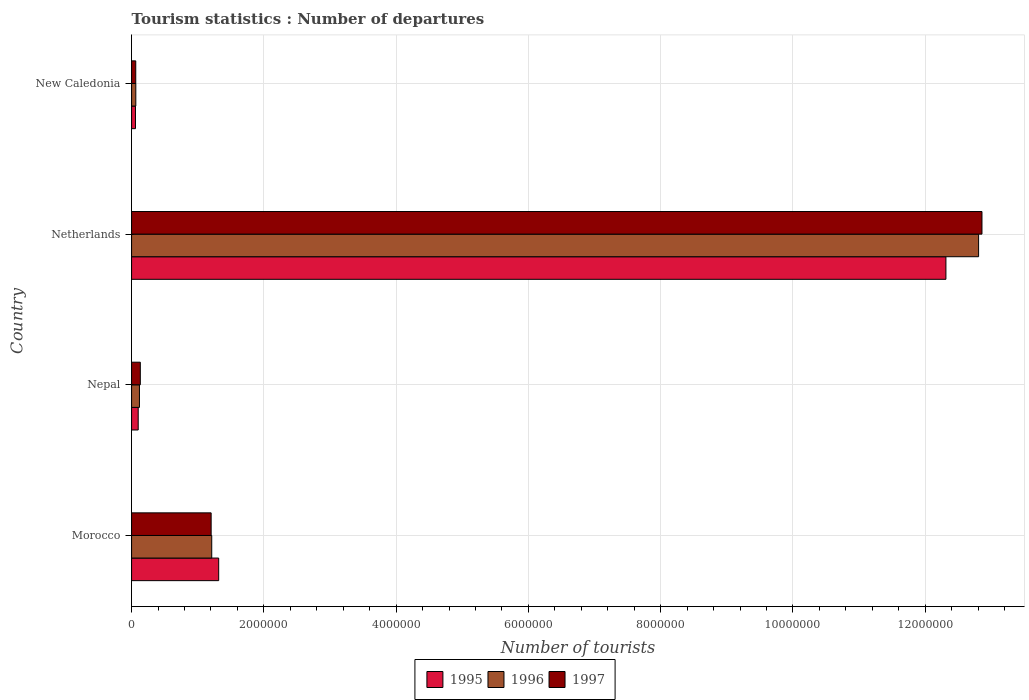How many different coloured bars are there?
Give a very brief answer. 3. Are the number of bars per tick equal to the number of legend labels?
Give a very brief answer. Yes. How many bars are there on the 1st tick from the bottom?
Give a very brief answer. 3. What is the label of the 2nd group of bars from the top?
Keep it short and to the point. Netherlands. In how many cases, is the number of bars for a given country not equal to the number of legend labels?
Keep it short and to the point. 0. What is the number of tourist departures in 1996 in Morocco?
Your answer should be very brief. 1.21e+06. Across all countries, what is the maximum number of tourist departures in 1996?
Give a very brief answer. 1.28e+07. Across all countries, what is the minimum number of tourist departures in 1995?
Ensure brevity in your answer.  5.90e+04. In which country was the number of tourist departures in 1996 maximum?
Your answer should be very brief. Netherlands. In which country was the number of tourist departures in 1997 minimum?
Keep it short and to the point. New Caledonia. What is the total number of tourist departures in 1996 in the graph?
Give a very brief answer. 1.42e+07. What is the difference between the number of tourist departures in 1995 in Nepal and that in Netherlands?
Your answer should be compact. -1.22e+07. What is the difference between the number of tourist departures in 1996 in Nepal and the number of tourist departures in 1997 in New Caledonia?
Make the answer very short. 5.60e+04. What is the average number of tourist departures in 1997 per country?
Your answer should be very brief. 3.56e+06. What is the difference between the number of tourist departures in 1995 and number of tourist departures in 1996 in Nepal?
Offer a very short reply. -1.90e+04. What is the ratio of the number of tourist departures in 1996 in Morocco to that in Nepal?
Your answer should be very brief. 10.18. Is the number of tourist departures in 1995 in Nepal less than that in Netherlands?
Provide a short and direct response. Yes. Is the difference between the number of tourist departures in 1995 in Nepal and Netherlands greater than the difference between the number of tourist departures in 1996 in Nepal and Netherlands?
Your answer should be compact. Yes. What is the difference between the highest and the second highest number of tourist departures in 1997?
Your response must be concise. 1.17e+07. What is the difference between the highest and the lowest number of tourist departures in 1995?
Ensure brevity in your answer.  1.23e+07. Is the sum of the number of tourist departures in 1995 in Morocco and Netherlands greater than the maximum number of tourist departures in 1996 across all countries?
Make the answer very short. Yes. What does the 1st bar from the top in Nepal represents?
Provide a succinct answer. 1997. What does the 1st bar from the bottom in Nepal represents?
Your response must be concise. 1995. Is it the case that in every country, the sum of the number of tourist departures in 1997 and number of tourist departures in 1995 is greater than the number of tourist departures in 1996?
Your answer should be very brief. Yes. How many bars are there?
Give a very brief answer. 12. Are the values on the major ticks of X-axis written in scientific E-notation?
Give a very brief answer. No. Does the graph contain grids?
Ensure brevity in your answer.  Yes. How many legend labels are there?
Your response must be concise. 3. What is the title of the graph?
Offer a terse response. Tourism statistics : Number of departures. Does "1966" appear as one of the legend labels in the graph?
Your response must be concise. No. What is the label or title of the X-axis?
Your answer should be compact. Number of tourists. What is the Number of tourists of 1995 in Morocco?
Your answer should be compact. 1.32e+06. What is the Number of tourists in 1996 in Morocco?
Ensure brevity in your answer.  1.21e+06. What is the Number of tourists in 1997 in Morocco?
Provide a short and direct response. 1.20e+06. What is the Number of tourists in 1995 in Nepal?
Give a very brief answer. 1.00e+05. What is the Number of tourists in 1996 in Nepal?
Your response must be concise. 1.19e+05. What is the Number of tourists in 1997 in Nepal?
Provide a short and direct response. 1.32e+05. What is the Number of tourists of 1995 in Netherlands?
Keep it short and to the point. 1.23e+07. What is the Number of tourists in 1996 in Netherlands?
Offer a terse response. 1.28e+07. What is the Number of tourists in 1997 in Netherlands?
Provide a short and direct response. 1.29e+07. What is the Number of tourists of 1995 in New Caledonia?
Make the answer very short. 5.90e+04. What is the Number of tourists in 1996 in New Caledonia?
Your answer should be very brief. 6.40e+04. What is the Number of tourists in 1997 in New Caledonia?
Offer a terse response. 6.30e+04. Across all countries, what is the maximum Number of tourists in 1995?
Give a very brief answer. 1.23e+07. Across all countries, what is the maximum Number of tourists of 1996?
Provide a succinct answer. 1.28e+07. Across all countries, what is the maximum Number of tourists in 1997?
Keep it short and to the point. 1.29e+07. Across all countries, what is the minimum Number of tourists in 1995?
Offer a very short reply. 5.90e+04. Across all countries, what is the minimum Number of tourists of 1996?
Provide a succinct answer. 6.40e+04. Across all countries, what is the minimum Number of tourists of 1997?
Your answer should be very brief. 6.30e+04. What is the total Number of tourists of 1995 in the graph?
Make the answer very short. 1.38e+07. What is the total Number of tourists of 1996 in the graph?
Make the answer very short. 1.42e+07. What is the total Number of tourists of 1997 in the graph?
Your answer should be very brief. 1.43e+07. What is the difference between the Number of tourists in 1995 in Morocco and that in Nepal?
Your response must be concise. 1.22e+06. What is the difference between the Number of tourists in 1996 in Morocco and that in Nepal?
Keep it short and to the point. 1.09e+06. What is the difference between the Number of tourists of 1997 in Morocco and that in Nepal?
Offer a terse response. 1.07e+06. What is the difference between the Number of tourists in 1995 in Morocco and that in Netherlands?
Offer a very short reply. -1.10e+07. What is the difference between the Number of tourists in 1996 in Morocco and that in Netherlands?
Make the answer very short. -1.16e+07. What is the difference between the Number of tourists in 1997 in Morocco and that in Netherlands?
Give a very brief answer. -1.17e+07. What is the difference between the Number of tourists in 1995 in Morocco and that in New Caledonia?
Offer a very short reply. 1.26e+06. What is the difference between the Number of tourists of 1996 in Morocco and that in New Caledonia?
Provide a succinct answer. 1.15e+06. What is the difference between the Number of tourists of 1997 in Morocco and that in New Caledonia?
Offer a very short reply. 1.14e+06. What is the difference between the Number of tourists of 1995 in Nepal and that in Netherlands?
Provide a succinct answer. -1.22e+07. What is the difference between the Number of tourists in 1996 in Nepal and that in Netherlands?
Make the answer very short. -1.27e+07. What is the difference between the Number of tourists in 1997 in Nepal and that in Netherlands?
Make the answer very short. -1.27e+07. What is the difference between the Number of tourists of 1995 in Nepal and that in New Caledonia?
Your response must be concise. 4.10e+04. What is the difference between the Number of tourists of 1996 in Nepal and that in New Caledonia?
Keep it short and to the point. 5.50e+04. What is the difference between the Number of tourists of 1997 in Nepal and that in New Caledonia?
Provide a succinct answer. 6.90e+04. What is the difference between the Number of tourists of 1995 in Netherlands and that in New Caledonia?
Your response must be concise. 1.23e+07. What is the difference between the Number of tourists in 1996 in Netherlands and that in New Caledonia?
Your answer should be very brief. 1.27e+07. What is the difference between the Number of tourists in 1997 in Netherlands and that in New Caledonia?
Keep it short and to the point. 1.28e+07. What is the difference between the Number of tourists in 1995 in Morocco and the Number of tourists in 1996 in Nepal?
Make the answer very short. 1.20e+06. What is the difference between the Number of tourists of 1995 in Morocco and the Number of tourists of 1997 in Nepal?
Your answer should be very brief. 1.18e+06. What is the difference between the Number of tourists in 1996 in Morocco and the Number of tourists in 1997 in Nepal?
Provide a succinct answer. 1.08e+06. What is the difference between the Number of tourists of 1995 in Morocco and the Number of tourists of 1996 in Netherlands?
Offer a terse response. -1.15e+07. What is the difference between the Number of tourists in 1995 in Morocco and the Number of tourists in 1997 in Netherlands?
Give a very brief answer. -1.15e+07. What is the difference between the Number of tourists of 1996 in Morocco and the Number of tourists of 1997 in Netherlands?
Give a very brief answer. -1.16e+07. What is the difference between the Number of tourists of 1995 in Morocco and the Number of tourists of 1996 in New Caledonia?
Offer a terse response. 1.25e+06. What is the difference between the Number of tourists of 1995 in Morocco and the Number of tourists of 1997 in New Caledonia?
Make the answer very short. 1.25e+06. What is the difference between the Number of tourists in 1996 in Morocco and the Number of tourists in 1997 in New Caledonia?
Keep it short and to the point. 1.15e+06. What is the difference between the Number of tourists of 1995 in Nepal and the Number of tourists of 1996 in Netherlands?
Keep it short and to the point. -1.27e+07. What is the difference between the Number of tourists in 1995 in Nepal and the Number of tourists in 1997 in Netherlands?
Your answer should be compact. -1.28e+07. What is the difference between the Number of tourists of 1996 in Nepal and the Number of tourists of 1997 in Netherlands?
Ensure brevity in your answer.  -1.27e+07. What is the difference between the Number of tourists of 1995 in Nepal and the Number of tourists of 1996 in New Caledonia?
Give a very brief answer. 3.60e+04. What is the difference between the Number of tourists in 1995 in Nepal and the Number of tourists in 1997 in New Caledonia?
Give a very brief answer. 3.70e+04. What is the difference between the Number of tourists in 1996 in Nepal and the Number of tourists in 1997 in New Caledonia?
Offer a very short reply. 5.60e+04. What is the difference between the Number of tourists in 1995 in Netherlands and the Number of tourists in 1996 in New Caledonia?
Give a very brief answer. 1.22e+07. What is the difference between the Number of tourists in 1995 in Netherlands and the Number of tourists in 1997 in New Caledonia?
Your answer should be very brief. 1.22e+07. What is the difference between the Number of tourists of 1996 in Netherlands and the Number of tourists of 1997 in New Caledonia?
Provide a succinct answer. 1.27e+07. What is the average Number of tourists of 1995 per country?
Give a very brief answer. 3.45e+06. What is the average Number of tourists in 1996 per country?
Provide a short and direct response. 3.55e+06. What is the average Number of tourists of 1997 per country?
Your answer should be compact. 3.56e+06. What is the difference between the Number of tourists of 1995 and Number of tourists of 1996 in Morocco?
Provide a short and direct response. 1.05e+05. What is the difference between the Number of tourists in 1995 and Number of tourists in 1997 in Morocco?
Make the answer very short. 1.14e+05. What is the difference between the Number of tourists in 1996 and Number of tourists in 1997 in Morocco?
Your response must be concise. 9000. What is the difference between the Number of tourists of 1995 and Number of tourists of 1996 in Nepal?
Keep it short and to the point. -1.90e+04. What is the difference between the Number of tourists in 1995 and Number of tourists in 1997 in Nepal?
Your answer should be compact. -3.20e+04. What is the difference between the Number of tourists of 1996 and Number of tourists of 1997 in Nepal?
Your answer should be compact. -1.30e+04. What is the difference between the Number of tourists of 1995 and Number of tourists of 1996 in Netherlands?
Offer a very short reply. -4.94e+05. What is the difference between the Number of tourists of 1995 and Number of tourists of 1997 in Netherlands?
Make the answer very short. -5.45e+05. What is the difference between the Number of tourists of 1996 and Number of tourists of 1997 in Netherlands?
Your response must be concise. -5.10e+04. What is the difference between the Number of tourists of 1995 and Number of tourists of 1996 in New Caledonia?
Your answer should be very brief. -5000. What is the difference between the Number of tourists in 1995 and Number of tourists in 1997 in New Caledonia?
Offer a terse response. -4000. What is the ratio of the Number of tourists in 1995 in Morocco to that in Nepal?
Provide a succinct answer. 13.17. What is the ratio of the Number of tourists in 1996 in Morocco to that in Nepal?
Make the answer very short. 10.18. What is the ratio of the Number of tourists in 1997 in Morocco to that in Nepal?
Your answer should be compact. 9.11. What is the ratio of the Number of tourists in 1995 in Morocco to that in Netherlands?
Ensure brevity in your answer.  0.11. What is the ratio of the Number of tourists in 1996 in Morocco to that in Netherlands?
Keep it short and to the point. 0.09. What is the ratio of the Number of tourists in 1997 in Morocco to that in Netherlands?
Keep it short and to the point. 0.09. What is the ratio of the Number of tourists of 1995 in Morocco to that in New Caledonia?
Keep it short and to the point. 22.32. What is the ratio of the Number of tourists in 1996 in Morocco to that in New Caledonia?
Your response must be concise. 18.94. What is the ratio of the Number of tourists in 1997 in Morocco to that in New Caledonia?
Offer a terse response. 19.1. What is the ratio of the Number of tourists of 1995 in Nepal to that in Netherlands?
Your response must be concise. 0.01. What is the ratio of the Number of tourists of 1996 in Nepal to that in Netherlands?
Provide a short and direct response. 0.01. What is the ratio of the Number of tourists in 1997 in Nepal to that in Netherlands?
Your response must be concise. 0.01. What is the ratio of the Number of tourists in 1995 in Nepal to that in New Caledonia?
Make the answer very short. 1.69. What is the ratio of the Number of tourists in 1996 in Nepal to that in New Caledonia?
Provide a succinct answer. 1.86. What is the ratio of the Number of tourists of 1997 in Nepal to that in New Caledonia?
Ensure brevity in your answer.  2.1. What is the ratio of the Number of tourists in 1995 in Netherlands to that in New Caledonia?
Offer a very short reply. 208.69. What is the ratio of the Number of tourists of 1996 in Netherlands to that in New Caledonia?
Ensure brevity in your answer.  200.11. What is the ratio of the Number of tourists of 1997 in Netherlands to that in New Caledonia?
Your answer should be compact. 204.1. What is the difference between the highest and the second highest Number of tourists in 1995?
Offer a terse response. 1.10e+07. What is the difference between the highest and the second highest Number of tourists in 1996?
Give a very brief answer. 1.16e+07. What is the difference between the highest and the second highest Number of tourists of 1997?
Keep it short and to the point. 1.17e+07. What is the difference between the highest and the lowest Number of tourists of 1995?
Give a very brief answer. 1.23e+07. What is the difference between the highest and the lowest Number of tourists of 1996?
Offer a terse response. 1.27e+07. What is the difference between the highest and the lowest Number of tourists in 1997?
Make the answer very short. 1.28e+07. 